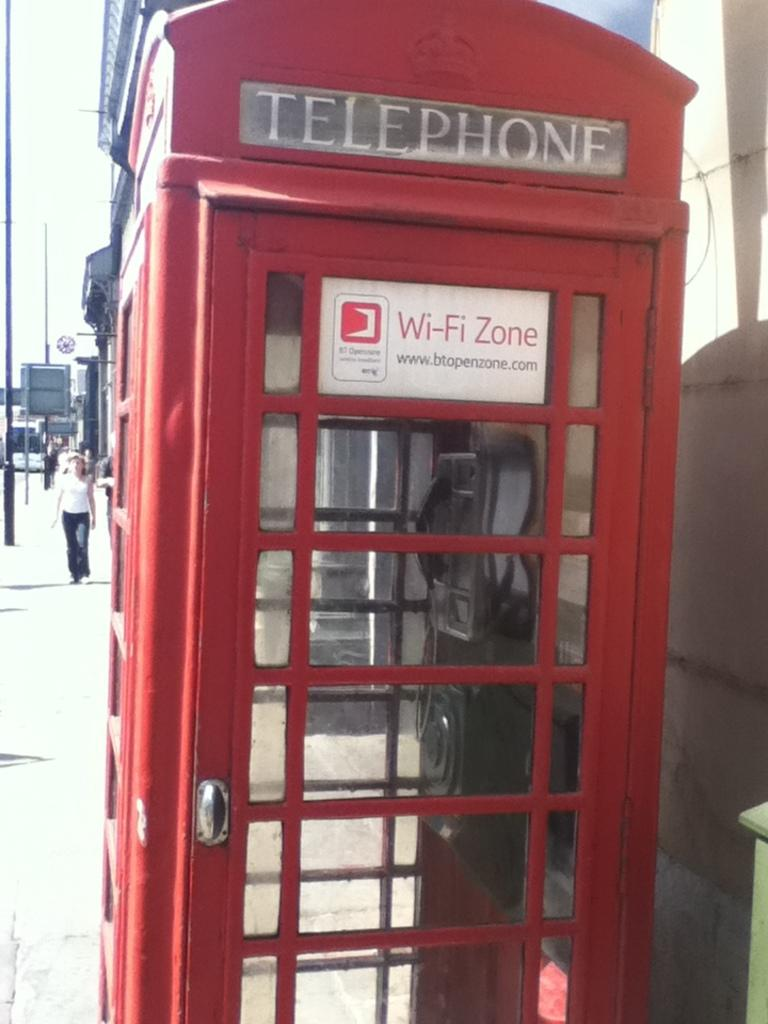<image>
Summarize the visual content of the image. A classic English red phone box has a wi-fi zone sign stuck on it. 